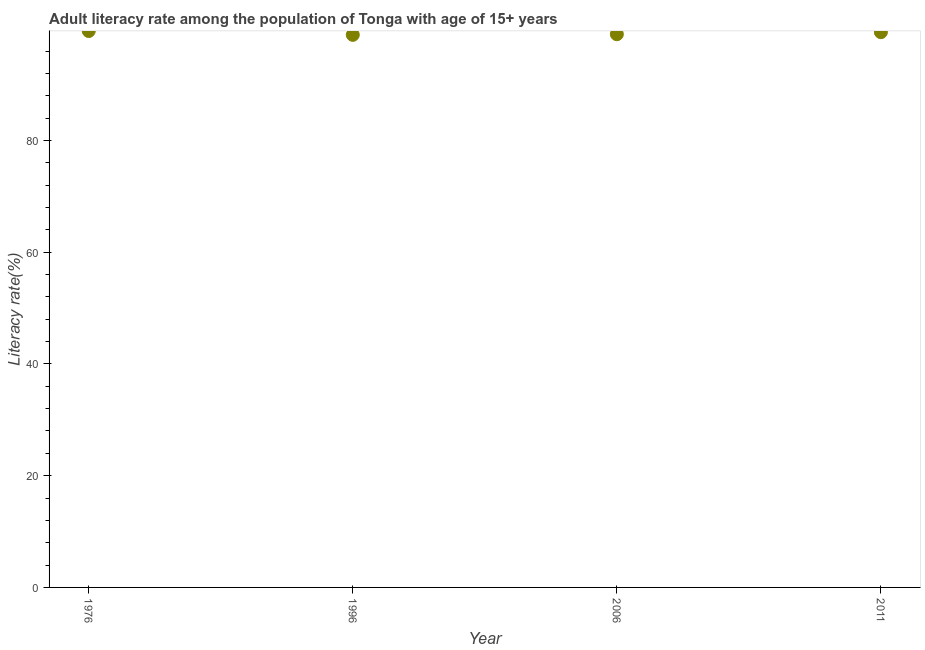What is the adult literacy rate in 2011?
Make the answer very short. 99.39. Across all years, what is the maximum adult literacy rate?
Keep it short and to the point. 99.59. Across all years, what is the minimum adult literacy rate?
Your answer should be compact. 98.91. In which year was the adult literacy rate maximum?
Offer a terse response. 1976. In which year was the adult literacy rate minimum?
Make the answer very short. 1996. What is the sum of the adult literacy rate?
Ensure brevity in your answer.  396.9. What is the difference between the adult literacy rate in 1976 and 1996?
Your answer should be very brief. 0.69. What is the average adult literacy rate per year?
Provide a short and direct response. 99.23. What is the median adult literacy rate?
Your answer should be compact. 99.2. What is the ratio of the adult literacy rate in 1976 to that in 2006?
Ensure brevity in your answer.  1.01. Is the adult literacy rate in 1976 less than that in 2011?
Provide a short and direct response. No. What is the difference between the highest and the second highest adult literacy rate?
Provide a short and direct response. 0.21. What is the difference between the highest and the lowest adult literacy rate?
Your answer should be very brief. 0.69. In how many years, is the adult literacy rate greater than the average adult literacy rate taken over all years?
Offer a very short reply. 2. What is the title of the graph?
Keep it short and to the point. Adult literacy rate among the population of Tonga with age of 15+ years. What is the label or title of the Y-axis?
Your answer should be compact. Literacy rate(%). What is the Literacy rate(%) in 1976?
Offer a very short reply. 99.59. What is the Literacy rate(%) in 1996?
Offer a very short reply. 98.91. What is the Literacy rate(%) in 2006?
Your response must be concise. 99.02. What is the Literacy rate(%) in 2011?
Ensure brevity in your answer.  99.39. What is the difference between the Literacy rate(%) in 1976 and 1996?
Offer a very short reply. 0.69. What is the difference between the Literacy rate(%) in 1976 and 2006?
Ensure brevity in your answer.  0.57. What is the difference between the Literacy rate(%) in 1976 and 2011?
Provide a short and direct response. 0.21. What is the difference between the Literacy rate(%) in 1996 and 2006?
Your response must be concise. -0.11. What is the difference between the Literacy rate(%) in 1996 and 2011?
Keep it short and to the point. -0.48. What is the difference between the Literacy rate(%) in 2006 and 2011?
Provide a succinct answer. -0.37. What is the ratio of the Literacy rate(%) in 1996 to that in 2006?
Your response must be concise. 1. What is the ratio of the Literacy rate(%) in 1996 to that in 2011?
Your response must be concise. 0.99. 